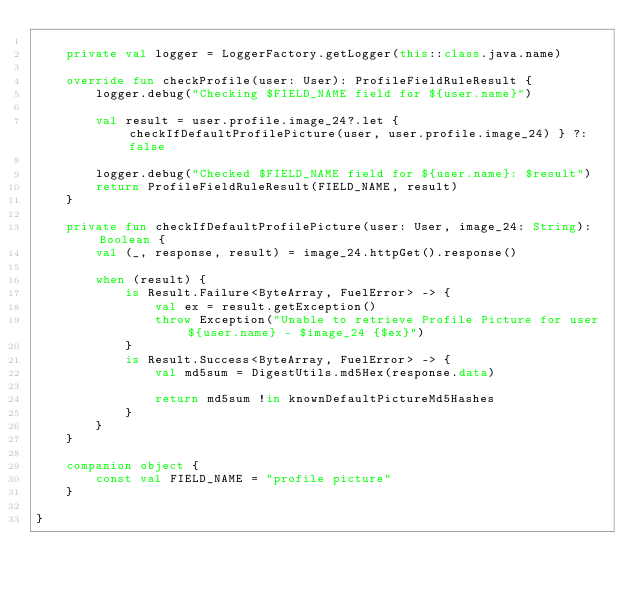Convert code to text. <code><loc_0><loc_0><loc_500><loc_500><_Kotlin_>
    private val logger = LoggerFactory.getLogger(this::class.java.name)

    override fun checkProfile(user: User): ProfileFieldRuleResult {
        logger.debug("Checking $FIELD_NAME field for ${user.name}")

        val result = user.profile.image_24?.let { checkIfDefaultProfilePicture(user, user.profile.image_24) } ?: false

        logger.debug("Checked $FIELD_NAME field for ${user.name}: $result")
        return ProfileFieldRuleResult(FIELD_NAME, result)
    }

    private fun checkIfDefaultProfilePicture(user: User, image_24: String): Boolean {
        val (_, response, result) = image_24.httpGet().response()

        when (result) {
            is Result.Failure<ByteArray, FuelError> -> {
                val ex = result.getException()
                throw Exception("Unable to retrieve Profile Picture for user ${user.name} - $image_24 {$ex}")
            }
            is Result.Success<ByteArray, FuelError> -> {
                val md5sum = DigestUtils.md5Hex(response.data)

                return md5sum !in knownDefaultPictureMd5Hashes
            }
        }
    }

    companion object {
        const val FIELD_NAME = "profile picture"
    }

}
</code> 